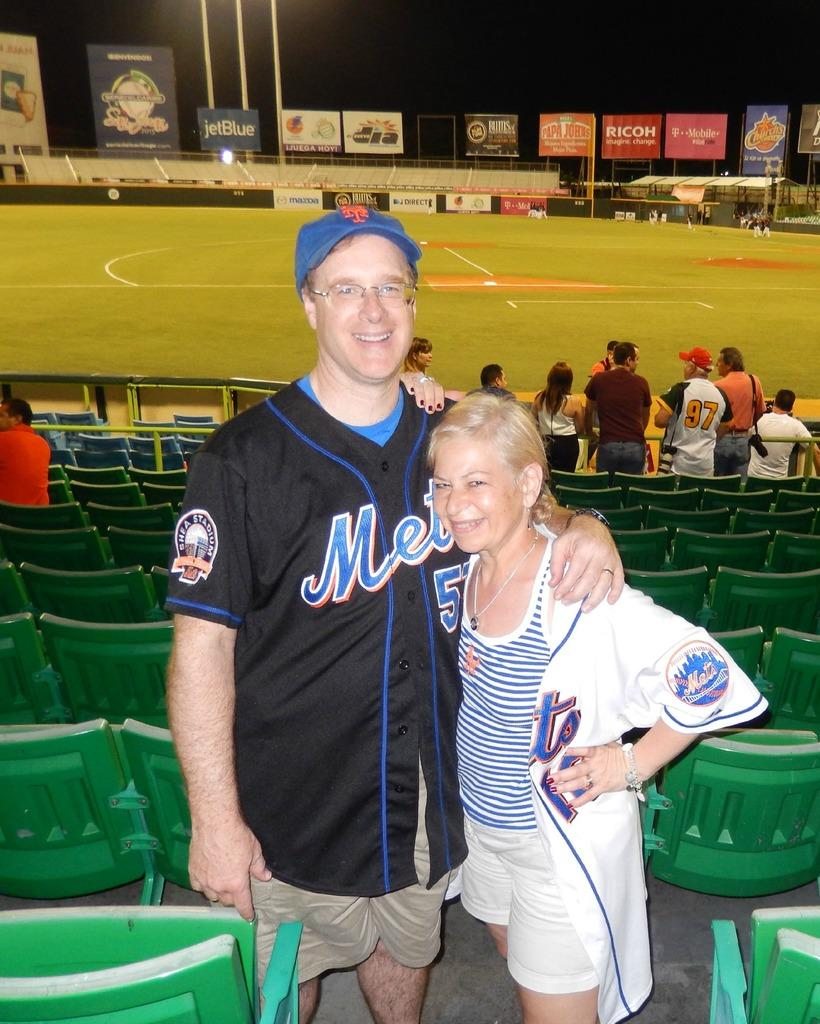<image>
Provide a brief description of the given image. A lady with a ball on her shirt that says Mets on it 